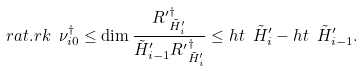<formula> <loc_0><loc_0><loc_500><loc_500>r a t . r k \ \nu ^ { \dag } _ { i 0 } \leq \dim \frac { { R ^ { \prime } } ^ { \dag } _ { \tilde { H } ^ { \prime } _ { i } } } { \tilde { H } ^ { \prime } _ { i - 1 } { R ^ { \prime } } ^ { \dag } _ { \tilde { H } ^ { \prime } _ { i } } } \leq h t \ \tilde { H } ^ { \prime } _ { i } - h t \ \tilde { H } ^ { \prime } _ { i - 1 } .</formula> 